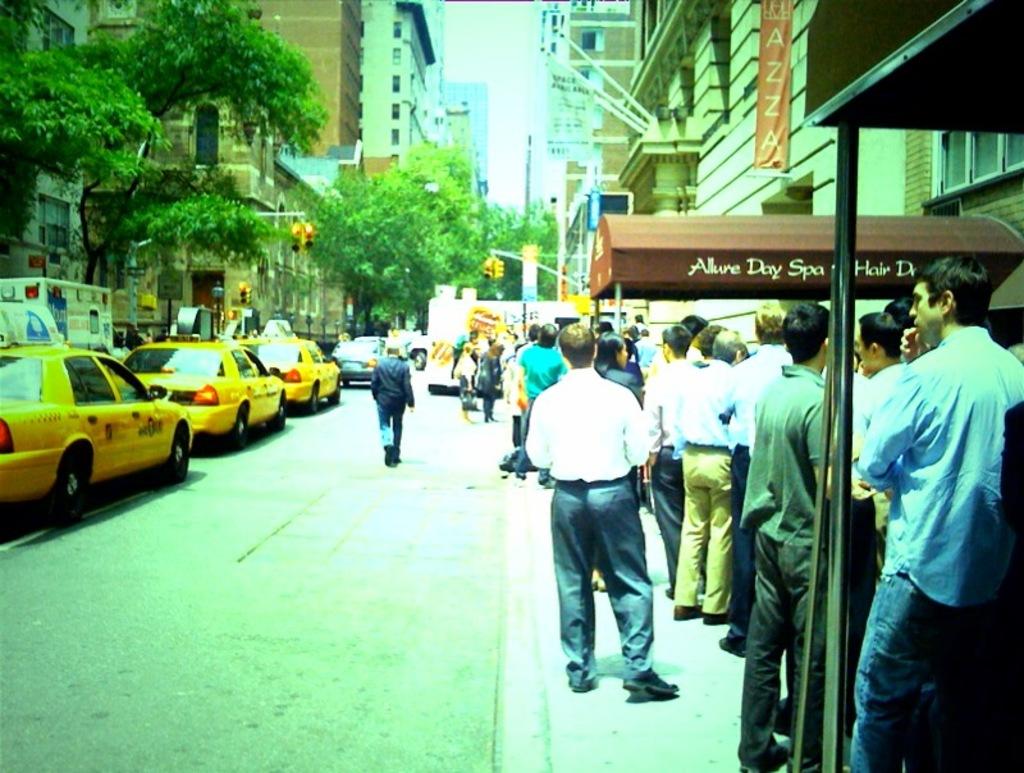What is the name of the spa?
Your answer should be very brief. Allure day spa. What does the orange sing say?
Offer a terse response. Azza. 